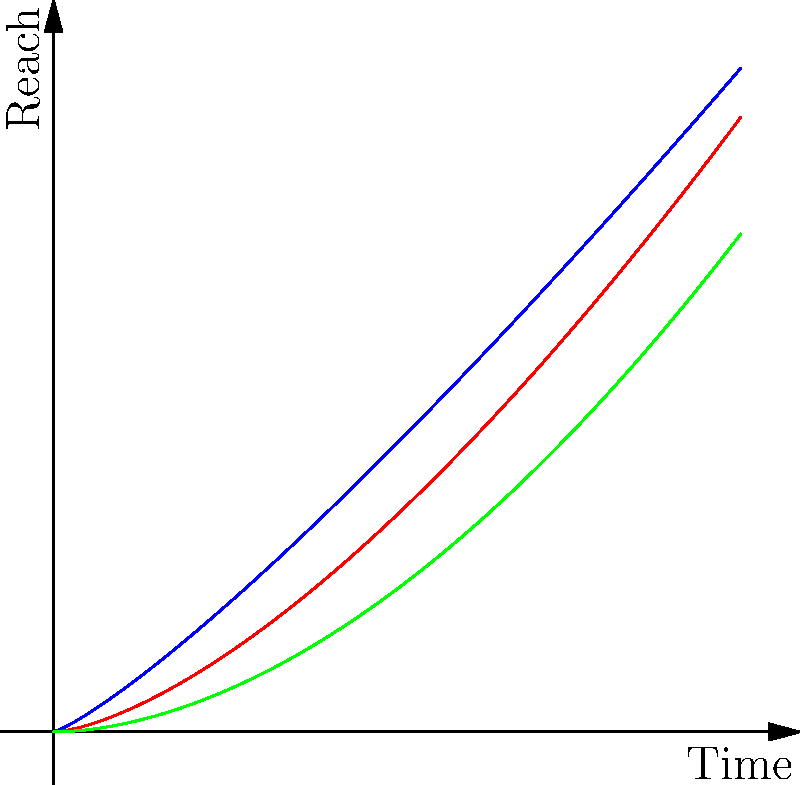The graph shows the fractal dimensions of propaganda dissemination patterns across different media channels during the Cold War. Given that the fractal dimension $D$ is related to the power law exponent $\alpha$ by the equation $D = 2 - \alpha$, which media channel exhibits the highest fractal dimension in its dissemination pattern? To determine which media channel has the highest fractal dimension, we need to follow these steps:

1. Identify the power law functions for each media channel:
   Television: $y = 0.7x^{1.2}$
   Radio: $y = 0.4x^{1.5}$
   Print: $y = 0.2x^{1.8}$

2. Extract the power law exponent $\alpha$ for each channel:
   Television: $\alpha_{TV} = 1.2$
   Radio: $\alpha_{Radio} = 1.5$
   Print: $\alpha_{Print} = 1.8$

3. Calculate the fractal dimension $D$ for each channel using $D = 2 - \alpha$:
   Television: $D_{TV} = 2 - 1.2 = 0.8$
   Radio: $D_{Radio} = 2 - 1.5 = 0.5$
   Print: $D_{Print} = 2 - 1.8 = 0.2$

4. Compare the fractal dimensions:
   $D_{TV} (0.8) > D_{Radio} (0.5) > D_{Print} (0.2)$

Therefore, television exhibits the highest fractal dimension in its propaganda dissemination pattern.
Answer: Television 